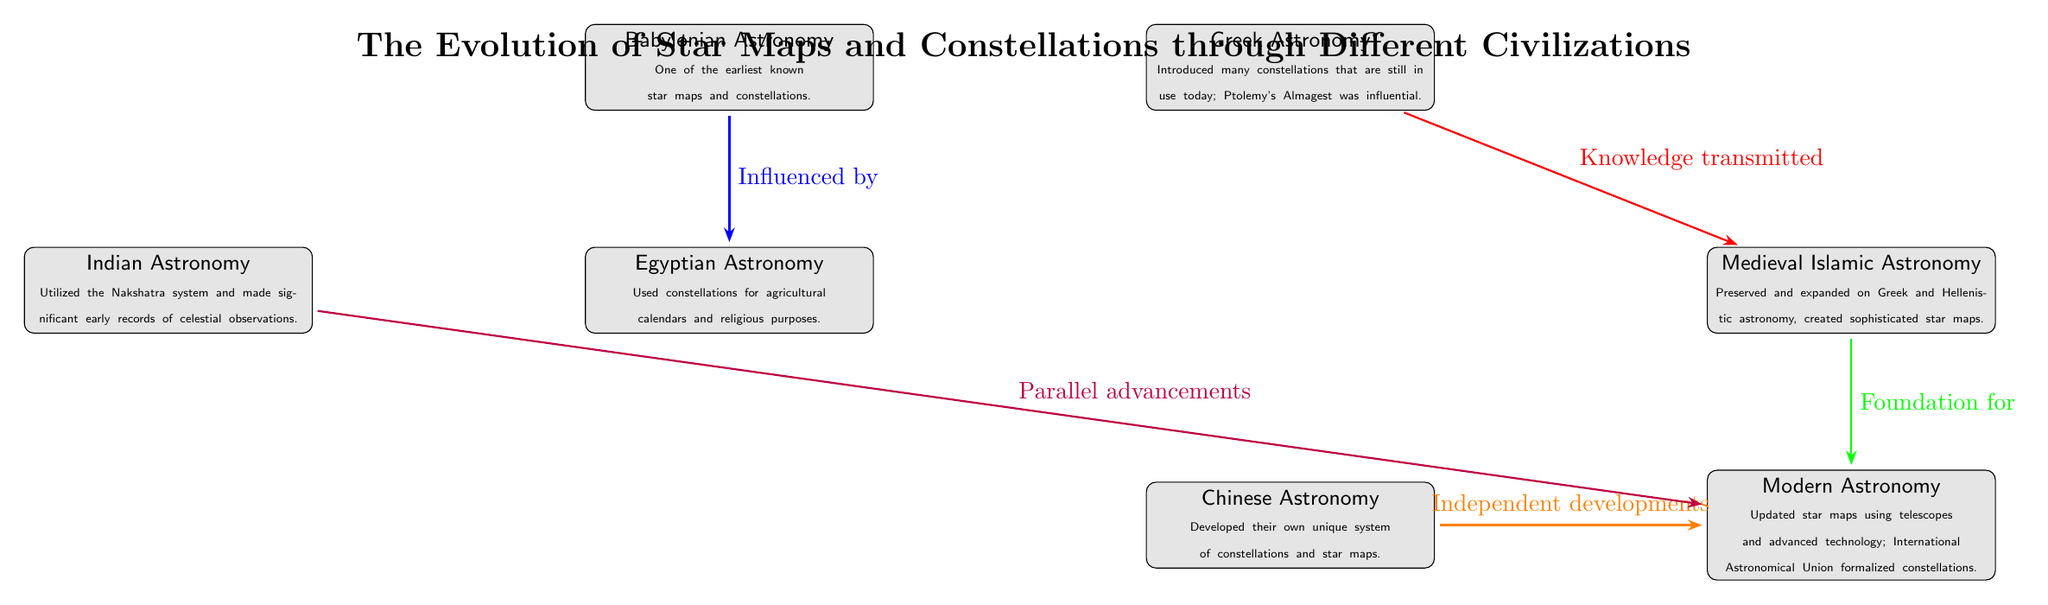What civilization is known for creating one of the earliest star maps? The diagram identifies Babylonian Astronomy as a civilization known for creating one of the earliest star maps. This information is explicitly stated in the description within the Babylonian node.
Answer: Babylonian Which civilization's astronomy was focused on agricultural calendars and religious purposes? The Egyptian Astronomy node specifies that constellations were used for agricultural calendars and religious purposes, thus linking this civilization directly to that characteristic.
Answer: Egyptian How many civilizations are illustrated in the diagram? By counting the nodes from Babylonian, Egyptian, Greek, Medieval Islamic, Modern, Chinese, and Indian, one can confirm a total of seven distinct civilizations is illustrated in the diagram.
Answer: 7 Which civilization influenced Egyptian Astronomy according to the diagram? The diagram indicates that the arrow pointing from Babylonian to Egyptian is labeled "Influenced by," establishing the relationship where Babylonian Astronomy had an influence on Egypt.
Answer: Babylonian What relationship connects Greek Astronomy to Medieval Islamic Astronomy? The arrow from Greek to Medieval Islamic marked "Knowledge transmitted" indicates that this is the specific relationship that connects the two civilizations.
Answer: Knowledge transmitted What did Medieval Islamic Astronomy provide for Modern Astronomy? The diagram states that Medieval Islamic Astronomy is the foundation for Modern Astronomy, as represented by the arrow labeled "Foundation for." This shows the direct support and development from one to the other.
Answer: Foundation for Which two civilizations developed their own unique systems of star maps? The diagram shows that both Chinese and Indian Astronomy created unique systems, highlighted by their connections to Modern Astronomy through independent developments and parallel advancements respectively.
Answer: Chinese, Indian Which civilization is described as preserving and expanding Greek astronomy? The Medieval Islamic Astronomy node notes that it preserved and expanded upon Greek and Hellenistic astronomy, directly linking it to this particular characteristic.
Answer: Medieval Islamic Which civilization's advancements were described as parallel to Modern Astronomy? The arrow labeled "Parallel advancements" connects from Indian Astronomy to Modern Astronomy, indicating that Indian developments were parallel to those of Modern Astronomy.
Answer: Indian 